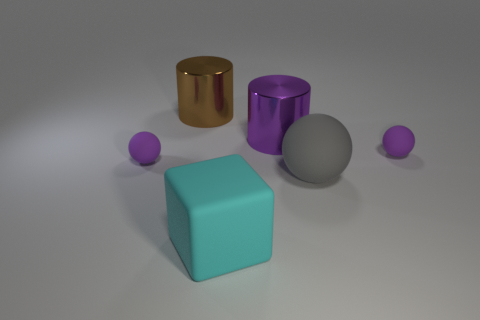Are there any other things that are the same shape as the large cyan rubber object?
Offer a very short reply. No. There is a metallic thing on the right side of the cyan matte thing; is it the same size as the big cyan matte block?
Keep it short and to the point. Yes. What is the shape of the big brown metallic object?
Your answer should be very brief. Cylinder. Is the material of the tiny thing left of the purple metallic object the same as the big cyan cube?
Ensure brevity in your answer.  Yes. There is a tiny object that is left of the gray rubber ball; does it have the same shape as the brown thing behind the large cyan block?
Keep it short and to the point. No. Is there a cyan block made of the same material as the gray sphere?
Offer a very short reply. Yes. How many purple things are either large balls or small rubber balls?
Your response must be concise. 2. What is the size of the matte object that is both behind the large matte ball and left of the purple cylinder?
Keep it short and to the point. Small. Are there more small spheres that are on the right side of the large cyan object than metal blocks?
Make the answer very short. Yes. How many cubes are either large shiny objects or cyan rubber objects?
Your response must be concise. 1. 